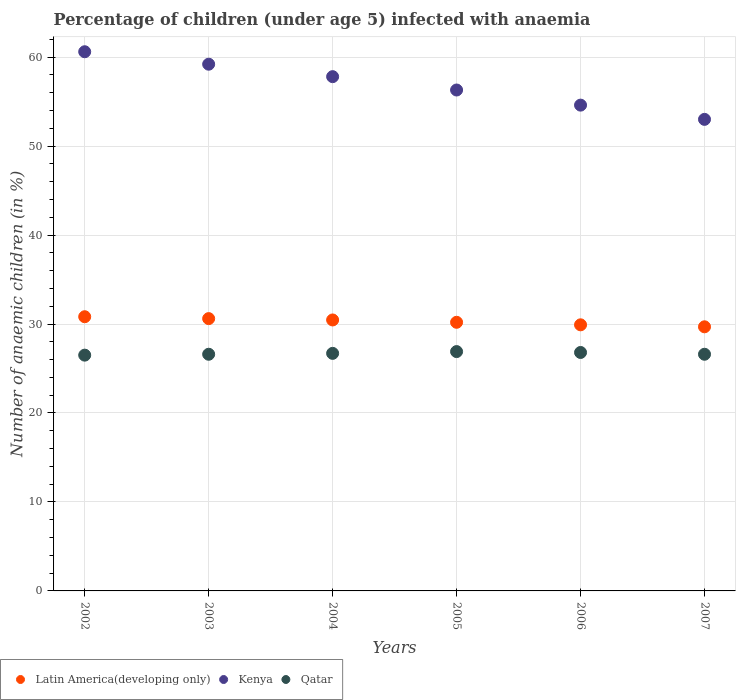What is the percentage of children infected with anaemia in in Kenya in 2006?
Give a very brief answer. 54.6. Across all years, what is the maximum percentage of children infected with anaemia in in Qatar?
Your answer should be very brief. 26.9. In which year was the percentage of children infected with anaemia in in Kenya minimum?
Your response must be concise. 2007. What is the total percentage of children infected with anaemia in in Kenya in the graph?
Provide a short and direct response. 341.5. What is the difference between the percentage of children infected with anaemia in in Kenya in 2004 and that in 2007?
Offer a very short reply. 4.8. What is the difference between the percentage of children infected with anaemia in in Qatar in 2004 and the percentage of children infected with anaemia in in Kenya in 2005?
Offer a terse response. -29.6. What is the average percentage of children infected with anaemia in in Kenya per year?
Ensure brevity in your answer.  56.92. In the year 2007, what is the difference between the percentage of children infected with anaemia in in Latin America(developing only) and percentage of children infected with anaemia in in Kenya?
Make the answer very short. -23.31. In how many years, is the percentage of children infected with anaemia in in Kenya greater than 42 %?
Ensure brevity in your answer.  6. What is the ratio of the percentage of children infected with anaemia in in Qatar in 2004 to that in 2006?
Offer a very short reply. 1. What is the difference between the highest and the second highest percentage of children infected with anaemia in in Latin America(developing only)?
Your answer should be very brief. 0.21. What is the difference between the highest and the lowest percentage of children infected with anaemia in in Kenya?
Provide a short and direct response. 7.6. In how many years, is the percentage of children infected with anaemia in in Kenya greater than the average percentage of children infected with anaemia in in Kenya taken over all years?
Your answer should be very brief. 3. Is it the case that in every year, the sum of the percentage of children infected with anaemia in in Kenya and percentage of children infected with anaemia in in Latin America(developing only)  is greater than the percentage of children infected with anaemia in in Qatar?
Keep it short and to the point. Yes. Does the percentage of children infected with anaemia in in Kenya monotonically increase over the years?
Offer a very short reply. No. Is the percentage of children infected with anaemia in in Kenya strictly less than the percentage of children infected with anaemia in in Latin America(developing only) over the years?
Your answer should be compact. No. How many years are there in the graph?
Your response must be concise. 6. What is the difference between two consecutive major ticks on the Y-axis?
Ensure brevity in your answer.  10. Are the values on the major ticks of Y-axis written in scientific E-notation?
Ensure brevity in your answer.  No. Does the graph contain any zero values?
Make the answer very short. No. Where does the legend appear in the graph?
Provide a short and direct response. Bottom left. How many legend labels are there?
Offer a very short reply. 3. How are the legend labels stacked?
Give a very brief answer. Horizontal. What is the title of the graph?
Keep it short and to the point. Percentage of children (under age 5) infected with anaemia. Does "Cayman Islands" appear as one of the legend labels in the graph?
Your response must be concise. No. What is the label or title of the Y-axis?
Keep it short and to the point. Number of anaemic children (in %). What is the Number of anaemic children (in %) in Latin America(developing only) in 2002?
Your answer should be very brief. 30.82. What is the Number of anaemic children (in %) in Kenya in 2002?
Keep it short and to the point. 60.6. What is the Number of anaemic children (in %) in Latin America(developing only) in 2003?
Your answer should be compact. 30.61. What is the Number of anaemic children (in %) of Kenya in 2003?
Offer a very short reply. 59.2. What is the Number of anaemic children (in %) in Qatar in 2003?
Your answer should be very brief. 26.6. What is the Number of anaemic children (in %) in Latin America(developing only) in 2004?
Provide a succinct answer. 30.45. What is the Number of anaemic children (in %) of Kenya in 2004?
Your answer should be compact. 57.8. What is the Number of anaemic children (in %) of Qatar in 2004?
Offer a very short reply. 26.7. What is the Number of anaemic children (in %) of Latin America(developing only) in 2005?
Your answer should be compact. 30.19. What is the Number of anaemic children (in %) of Kenya in 2005?
Keep it short and to the point. 56.3. What is the Number of anaemic children (in %) in Qatar in 2005?
Your answer should be compact. 26.9. What is the Number of anaemic children (in %) in Latin America(developing only) in 2006?
Offer a terse response. 29.91. What is the Number of anaemic children (in %) in Kenya in 2006?
Your answer should be compact. 54.6. What is the Number of anaemic children (in %) of Qatar in 2006?
Make the answer very short. 26.8. What is the Number of anaemic children (in %) of Latin America(developing only) in 2007?
Offer a very short reply. 29.69. What is the Number of anaemic children (in %) of Qatar in 2007?
Your answer should be very brief. 26.6. Across all years, what is the maximum Number of anaemic children (in %) in Latin America(developing only)?
Keep it short and to the point. 30.82. Across all years, what is the maximum Number of anaemic children (in %) of Kenya?
Your answer should be compact. 60.6. Across all years, what is the maximum Number of anaemic children (in %) in Qatar?
Make the answer very short. 26.9. Across all years, what is the minimum Number of anaemic children (in %) of Latin America(developing only)?
Keep it short and to the point. 29.69. Across all years, what is the minimum Number of anaemic children (in %) of Kenya?
Offer a very short reply. 53. Across all years, what is the minimum Number of anaemic children (in %) in Qatar?
Ensure brevity in your answer.  26.5. What is the total Number of anaemic children (in %) in Latin America(developing only) in the graph?
Ensure brevity in your answer.  181.66. What is the total Number of anaemic children (in %) of Kenya in the graph?
Provide a succinct answer. 341.5. What is the total Number of anaemic children (in %) of Qatar in the graph?
Give a very brief answer. 160.1. What is the difference between the Number of anaemic children (in %) in Latin America(developing only) in 2002 and that in 2003?
Offer a terse response. 0.21. What is the difference between the Number of anaemic children (in %) of Latin America(developing only) in 2002 and that in 2004?
Your answer should be compact. 0.36. What is the difference between the Number of anaemic children (in %) of Qatar in 2002 and that in 2004?
Provide a short and direct response. -0.2. What is the difference between the Number of anaemic children (in %) in Latin America(developing only) in 2002 and that in 2005?
Offer a very short reply. 0.63. What is the difference between the Number of anaemic children (in %) of Latin America(developing only) in 2002 and that in 2006?
Your answer should be compact. 0.91. What is the difference between the Number of anaemic children (in %) of Latin America(developing only) in 2002 and that in 2007?
Your response must be concise. 1.13. What is the difference between the Number of anaemic children (in %) in Kenya in 2002 and that in 2007?
Your response must be concise. 7.6. What is the difference between the Number of anaemic children (in %) in Qatar in 2002 and that in 2007?
Provide a succinct answer. -0.1. What is the difference between the Number of anaemic children (in %) in Latin America(developing only) in 2003 and that in 2004?
Your answer should be compact. 0.15. What is the difference between the Number of anaemic children (in %) of Kenya in 2003 and that in 2004?
Offer a very short reply. 1.4. What is the difference between the Number of anaemic children (in %) of Qatar in 2003 and that in 2004?
Keep it short and to the point. -0.1. What is the difference between the Number of anaemic children (in %) in Latin America(developing only) in 2003 and that in 2005?
Keep it short and to the point. 0.41. What is the difference between the Number of anaemic children (in %) in Kenya in 2003 and that in 2005?
Provide a short and direct response. 2.9. What is the difference between the Number of anaemic children (in %) of Qatar in 2003 and that in 2005?
Provide a succinct answer. -0.3. What is the difference between the Number of anaemic children (in %) of Latin America(developing only) in 2003 and that in 2006?
Provide a succinct answer. 0.7. What is the difference between the Number of anaemic children (in %) of Kenya in 2003 and that in 2006?
Your answer should be very brief. 4.6. What is the difference between the Number of anaemic children (in %) of Latin America(developing only) in 2003 and that in 2007?
Offer a very short reply. 0.92. What is the difference between the Number of anaemic children (in %) in Latin America(developing only) in 2004 and that in 2005?
Your answer should be compact. 0.26. What is the difference between the Number of anaemic children (in %) of Qatar in 2004 and that in 2005?
Give a very brief answer. -0.2. What is the difference between the Number of anaemic children (in %) of Latin America(developing only) in 2004 and that in 2006?
Make the answer very short. 0.55. What is the difference between the Number of anaemic children (in %) of Kenya in 2004 and that in 2006?
Keep it short and to the point. 3.2. What is the difference between the Number of anaemic children (in %) in Latin America(developing only) in 2004 and that in 2007?
Your answer should be compact. 0.77. What is the difference between the Number of anaemic children (in %) of Kenya in 2004 and that in 2007?
Your answer should be very brief. 4.8. What is the difference between the Number of anaemic children (in %) of Latin America(developing only) in 2005 and that in 2006?
Your response must be concise. 0.28. What is the difference between the Number of anaemic children (in %) of Qatar in 2005 and that in 2006?
Offer a very short reply. 0.1. What is the difference between the Number of anaemic children (in %) of Latin America(developing only) in 2005 and that in 2007?
Your answer should be compact. 0.51. What is the difference between the Number of anaemic children (in %) of Latin America(developing only) in 2006 and that in 2007?
Your answer should be very brief. 0.22. What is the difference between the Number of anaemic children (in %) of Kenya in 2006 and that in 2007?
Provide a succinct answer. 1.6. What is the difference between the Number of anaemic children (in %) of Qatar in 2006 and that in 2007?
Give a very brief answer. 0.2. What is the difference between the Number of anaemic children (in %) in Latin America(developing only) in 2002 and the Number of anaemic children (in %) in Kenya in 2003?
Offer a very short reply. -28.38. What is the difference between the Number of anaemic children (in %) in Latin America(developing only) in 2002 and the Number of anaemic children (in %) in Qatar in 2003?
Your answer should be compact. 4.22. What is the difference between the Number of anaemic children (in %) in Latin America(developing only) in 2002 and the Number of anaemic children (in %) in Kenya in 2004?
Give a very brief answer. -26.98. What is the difference between the Number of anaemic children (in %) of Latin America(developing only) in 2002 and the Number of anaemic children (in %) of Qatar in 2004?
Your answer should be very brief. 4.12. What is the difference between the Number of anaemic children (in %) of Kenya in 2002 and the Number of anaemic children (in %) of Qatar in 2004?
Keep it short and to the point. 33.9. What is the difference between the Number of anaemic children (in %) in Latin America(developing only) in 2002 and the Number of anaemic children (in %) in Kenya in 2005?
Your response must be concise. -25.48. What is the difference between the Number of anaemic children (in %) in Latin America(developing only) in 2002 and the Number of anaemic children (in %) in Qatar in 2005?
Keep it short and to the point. 3.92. What is the difference between the Number of anaemic children (in %) of Kenya in 2002 and the Number of anaemic children (in %) of Qatar in 2005?
Provide a succinct answer. 33.7. What is the difference between the Number of anaemic children (in %) in Latin America(developing only) in 2002 and the Number of anaemic children (in %) in Kenya in 2006?
Your answer should be very brief. -23.78. What is the difference between the Number of anaemic children (in %) of Latin America(developing only) in 2002 and the Number of anaemic children (in %) of Qatar in 2006?
Offer a very short reply. 4.02. What is the difference between the Number of anaemic children (in %) in Kenya in 2002 and the Number of anaemic children (in %) in Qatar in 2006?
Provide a succinct answer. 33.8. What is the difference between the Number of anaemic children (in %) of Latin America(developing only) in 2002 and the Number of anaemic children (in %) of Kenya in 2007?
Your response must be concise. -22.18. What is the difference between the Number of anaemic children (in %) of Latin America(developing only) in 2002 and the Number of anaemic children (in %) of Qatar in 2007?
Provide a succinct answer. 4.22. What is the difference between the Number of anaemic children (in %) in Kenya in 2002 and the Number of anaemic children (in %) in Qatar in 2007?
Give a very brief answer. 34. What is the difference between the Number of anaemic children (in %) of Latin America(developing only) in 2003 and the Number of anaemic children (in %) of Kenya in 2004?
Your answer should be compact. -27.19. What is the difference between the Number of anaemic children (in %) of Latin America(developing only) in 2003 and the Number of anaemic children (in %) of Qatar in 2004?
Your response must be concise. 3.91. What is the difference between the Number of anaemic children (in %) of Kenya in 2003 and the Number of anaemic children (in %) of Qatar in 2004?
Your response must be concise. 32.5. What is the difference between the Number of anaemic children (in %) of Latin America(developing only) in 2003 and the Number of anaemic children (in %) of Kenya in 2005?
Provide a succinct answer. -25.69. What is the difference between the Number of anaemic children (in %) in Latin America(developing only) in 2003 and the Number of anaemic children (in %) in Qatar in 2005?
Make the answer very short. 3.71. What is the difference between the Number of anaemic children (in %) in Kenya in 2003 and the Number of anaemic children (in %) in Qatar in 2005?
Offer a terse response. 32.3. What is the difference between the Number of anaemic children (in %) of Latin America(developing only) in 2003 and the Number of anaemic children (in %) of Kenya in 2006?
Make the answer very short. -23.99. What is the difference between the Number of anaemic children (in %) in Latin America(developing only) in 2003 and the Number of anaemic children (in %) in Qatar in 2006?
Provide a succinct answer. 3.81. What is the difference between the Number of anaemic children (in %) of Kenya in 2003 and the Number of anaemic children (in %) of Qatar in 2006?
Make the answer very short. 32.4. What is the difference between the Number of anaemic children (in %) of Latin America(developing only) in 2003 and the Number of anaemic children (in %) of Kenya in 2007?
Your response must be concise. -22.39. What is the difference between the Number of anaemic children (in %) in Latin America(developing only) in 2003 and the Number of anaemic children (in %) in Qatar in 2007?
Your answer should be very brief. 4.01. What is the difference between the Number of anaemic children (in %) of Kenya in 2003 and the Number of anaemic children (in %) of Qatar in 2007?
Make the answer very short. 32.6. What is the difference between the Number of anaemic children (in %) in Latin America(developing only) in 2004 and the Number of anaemic children (in %) in Kenya in 2005?
Your answer should be compact. -25.85. What is the difference between the Number of anaemic children (in %) in Latin America(developing only) in 2004 and the Number of anaemic children (in %) in Qatar in 2005?
Your response must be concise. 3.55. What is the difference between the Number of anaemic children (in %) in Kenya in 2004 and the Number of anaemic children (in %) in Qatar in 2005?
Ensure brevity in your answer.  30.9. What is the difference between the Number of anaemic children (in %) in Latin America(developing only) in 2004 and the Number of anaemic children (in %) in Kenya in 2006?
Keep it short and to the point. -24.15. What is the difference between the Number of anaemic children (in %) of Latin America(developing only) in 2004 and the Number of anaemic children (in %) of Qatar in 2006?
Your answer should be very brief. 3.65. What is the difference between the Number of anaemic children (in %) in Kenya in 2004 and the Number of anaemic children (in %) in Qatar in 2006?
Your answer should be compact. 31. What is the difference between the Number of anaemic children (in %) in Latin America(developing only) in 2004 and the Number of anaemic children (in %) in Kenya in 2007?
Your response must be concise. -22.55. What is the difference between the Number of anaemic children (in %) of Latin America(developing only) in 2004 and the Number of anaemic children (in %) of Qatar in 2007?
Your response must be concise. 3.85. What is the difference between the Number of anaemic children (in %) of Kenya in 2004 and the Number of anaemic children (in %) of Qatar in 2007?
Your response must be concise. 31.2. What is the difference between the Number of anaemic children (in %) of Latin America(developing only) in 2005 and the Number of anaemic children (in %) of Kenya in 2006?
Keep it short and to the point. -24.41. What is the difference between the Number of anaemic children (in %) in Latin America(developing only) in 2005 and the Number of anaemic children (in %) in Qatar in 2006?
Give a very brief answer. 3.39. What is the difference between the Number of anaemic children (in %) in Kenya in 2005 and the Number of anaemic children (in %) in Qatar in 2006?
Your answer should be very brief. 29.5. What is the difference between the Number of anaemic children (in %) in Latin America(developing only) in 2005 and the Number of anaemic children (in %) in Kenya in 2007?
Your response must be concise. -22.81. What is the difference between the Number of anaemic children (in %) in Latin America(developing only) in 2005 and the Number of anaemic children (in %) in Qatar in 2007?
Your response must be concise. 3.59. What is the difference between the Number of anaemic children (in %) in Kenya in 2005 and the Number of anaemic children (in %) in Qatar in 2007?
Give a very brief answer. 29.7. What is the difference between the Number of anaemic children (in %) in Latin America(developing only) in 2006 and the Number of anaemic children (in %) in Kenya in 2007?
Your answer should be compact. -23.09. What is the difference between the Number of anaemic children (in %) of Latin America(developing only) in 2006 and the Number of anaemic children (in %) of Qatar in 2007?
Ensure brevity in your answer.  3.31. What is the average Number of anaemic children (in %) in Latin America(developing only) per year?
Ensure brevity in your answer.  30.28. What is the average Number of anaemic children (in %) of Kenya per year?
Offer a terse response. 56.92. What is the average Number of anaemic children (in %) of Qatar per year?
Give a very brief answer. 26.68. In the year 2002, what is the difference between the Number of anaemic children (in %) in Latin America(developing only) and Number of anaemic children (in %) in Kenya?
Provide a succinct answer. -29.78. In the year 2002, what is the difference between the Number of anaemic children (in %) in Latin America(developing only) and Number of anaemic children (in %) in Qatar?
Offer a terse response. 4.32. In the year 2002, what is the difference between the Number of anaemic children (in %) of Kenya and Number of anaemic children (in %) of Qatar?
Offer a terse response. 34.1. In the year 2003, what is the difference between the Number of anaemic children (in %) in Latin America(developing only) and Number of anaemic children (in %) in Kenya?
Provide a succinct answer. -28.59. In the year 2003, what is the difference between the Number of anaemic children (in %) in Latin America(developing only) and Number of anaemic children (in %) in Qatar?
Give a very brief answer. 4.01. In the year 2003, what is the difference between the Number of anaemic children (in %) of Kenya and Number of anaemic children (in %) of Qatar?
Your answer should be compact. 32.6. In the year 2004, what is the difference between the Number of anaemic children (in %) of Latin America(developing only) and Number of anaemic children (in %) of Kenya?
Your answer should be very brief. -27.35. In the year 2004, what is the difference between the Number of anaemic children (in %) in Latin America(developing only) and Number of anaemic children (in %) in Qatar?
Your answer should be compact. 3.75. In the year 2004, what is the difference between the Number of anaemic children (in %) of Kenya and Number of anaemic children (in %) of Qatar?
Offer a terse response. 31.1. In the year 2005, what is the difference between the Number of anaemic children (in %) of Latin America(developing only) and Number of anaemic children (in %) of Kenya?
Give a very brief answer. -26.11. In the year 2005, what is the difference between the Number of anaemic children (in %) in Latin America(developing only) and Number of anaemic children (in %) in Qatar?
Your response must be concise. 3.29. In the year 2005, what is the difference between the Number of anaemic children (in %) of Kenya and Number of anaemic children (in %) of Qatar?
Your answer should be compact. 29.4. In the year 2006, what is the difference between the Number of anaemic children (in %) of Latin America(developing only) and Number of anaemic children (in %) of Kenya?
Keep it short and to the point. -24.69. In the year 2006, what is the difference between the Number of anaemic children (in %) of Latin America(developing only) and Number of anaemic children (in %) of Qatar?
Your answer should be very brief. 3.11. In the year 2006, what is the difference between the Number of anaemic children (in %) in Kenya and Number of anaemic children (in %) in Qatar?
Your answer should be compact. 27.8. In the year 2007, what is the difference between the Number of anaemic children (in %) of Latin America(developing only) and Number of anaemic children (in %) of Kenya?
Your response must be concise. -23.31. In the year 2007, what is the difference between the Number of anaemic children (in %) of Latin America(developing only) and Number of anaemic children (in %) of Qatar?
Give a very brief answer. 3.09. In the year 2007, what is the difference between the Number of anaemic children (in %) in Kenya and Number of anaemic children (in %) in Qatar?
Keep it short and to the point. 26.4. What is the ratio of the Number of anaemic children (in %) in Latin America(developing only) in 2002 to that in 2003?
Provide a short and direct response. 1.01. What is the ratio of the Number of anaemic children (in %) of Kenya in 2002 to that in 2003?
Provide a short and direct response. 1.02. What is the ratio of the Number of anaemic children (in %) of Latin America(developing only) in 2002 to that in 2004?
Your answer should be very brief. 1.01. What is the ratio of the Number of anaemic children (in %) of Kenya in 2002 to that in 2004?
Your answer should be very brief. 1.05. What is the ratio of the Number of anaemic children (in %) in Qatar in 2002 to that in 2004?
Provide a succinct answer. 0.99. What is the ratio of the Number of anaemic children (in %) of Latin America(developing only) in 2002 to that in 2005?
Offer a terse response. 1.02. What is the ratio of the Number of anaemic children (in %) in Kenya in 2002 to that in 2005?
Offer a very short reply. 1.08. What is the ratio of the Number of anaemic children (in %) of Qatar in 2002 to that in 2005?
Your response must be concise. 0.99. What is the ratio of the Number of anaemic children (in %) in Latin America(developing only) in 2002 to that in 2006?
Make the answer very short. 1.03. What is the ratio of the Number of anaemic children (in %) of Kenya in 2002 to that in 2006?
Provide a succinct answer. 1.11. What is the ratio of the Number of anaemic children (in %) in Qatar in 2002 to that in 2006?
Provide a short and direct response. 0.99. What is the ratio of the Number of anaemic children (in %) in Latin America(developing only) in 2002 to that in 2007?
Ensure brevity in your answer.  1.04. What is the ratio of the Number of anaemic children (in %) of Kenya in 2002 to that in 2007?
Your response must be concise. 1.14. What is the ratio of the Number of anaemic children (in %) of Kenya in 2003 to that in 2004?
Offer a terse response. 1.02. What is the ratio of the Number of anaemic children (in %) of Latin America(developing only) in 2003 to that in 2005?
Offer a very short reply. 1.01. What is the ratio of the Number of anaemic children (in %) in Kenya in 2003 to that in 2005?
Provide a short and direct response. 1.05. What is the ratio of the Number of anaemic children (in %) of Latin America(developing only) in 2003 to that in 2006?
Make the answer very short. 1.02. What is the ratio of the Number of anaemic children (in %) of Kenya in 2003 to that in 2006?
Keep it short and to the point. 1.08. What is the ratio of the Number of anaemic children (in %) in Qatar in 2003 to that in 2006?
Your answer should be compact. 0.99. What is the ratio of the Number of anaemic children (in %) of Latin America(developing only) in 2003 to that in 2007?
Provide a short and direct response. 1.03. What is the ratio of the Number of anaemic children (in %) of Kenya in 2003 to that in 2007?
Ensure brevity in your answer.  1.12. What is the ratio of the Number of anaemic children (in %) in Latin America(developing only) in 2004 to that in 2005?
Make the answer very short. 1.01. What is the ratio of the Number of anaemic children (in %) of Kenya in 2004 to that in 2005?
Offer a terse response. 1.03. What is the ratio of the Number of anaemic children (in %) in Qatar in 2004 to that in 2005?
Provide a succinct answer. 0.99. What is the ratio of the Number of anaemic children (in %) of Latin America(developing only) in 2004 to that in 2006?
Keep it short and to the point. 1.02. What is the ratio of the Number of anaemic children (in %) in Kenya in 2004 to that in 2006?
Ensure brevity in your answer.  1.06. What is the ratio of the Number of anaemic children (in %) in Latin America(developing only) in 2004 to that in 2007?
Your answer should be compact. 1.03. What is the ratio of the Number of anaemic children (in %) of Kenya in 2004 to that in 2007?
Provide a short and direct response. 1.09. What is the ratio of the Number of anaemic children (in %) of Qatar in 2004 to that in 2007?
Ensure brevity in your answer.  1. What is the ratio of the Number of anaemic children (in %) of Latin America(developing only) in 2005 to that in 2006?
Provide a short and direct response. 1.01. What is the ratio of the Number of anaemic children (in %) of Kenya in 2005 to that in 2006?
Ensure brevity in your answer.  1.03. What is the ratio of the Number of anaemic children (in %) of Qatar in 2005 to that in 2006?
Give a very brief answer. 1. What is the ratio of the Number of anaemic children (in %) in Latin America(developing only) in 2005 to that in 2007?
Provide a succinct answer. 1.02. What is the ratio of the Number of anaemic children (in %) in Kenya in 2005 to that in 2007?
Offer a terse response. 1.06. What is the ratio of the Number of anaemic children (in %) of Qatar in 2005 to that in 2007?
Make the answer very short. 1.01. What is the ratio of the Number of anaemic children (in %) of Latin America(developing only) in 2006 to that in 2007?
Your answer should be compact. 1.01. What is the ratio of the Number of anaemic children (in %) in Kenya in 2006 to that in 2007?
Make the answer very short. 1.03. What is the ratio of the Number of anaemic children (in %) of Qatar in 2006 to that in 2007?
Keep it short and to the point. 1.01. What is the difference between the highest and the second highest Number of anaemic children (in %) of Latin America(developing only)?
Ensure brevity in your answer.  0.21. What is the difference between the highest and the second highest Number of anaemic children (in %) in Kenya?
Your answer should be compact. 1.4. What is the difference between the highest and the second highest Number of anaemic children (in %) of Qatar?
Offer a very short reply. 0.1. What is the difference between the highest and the lowest Number of anaemic children (in %) of Latin America(developing only)?
Your response must be concise. 1.13. 